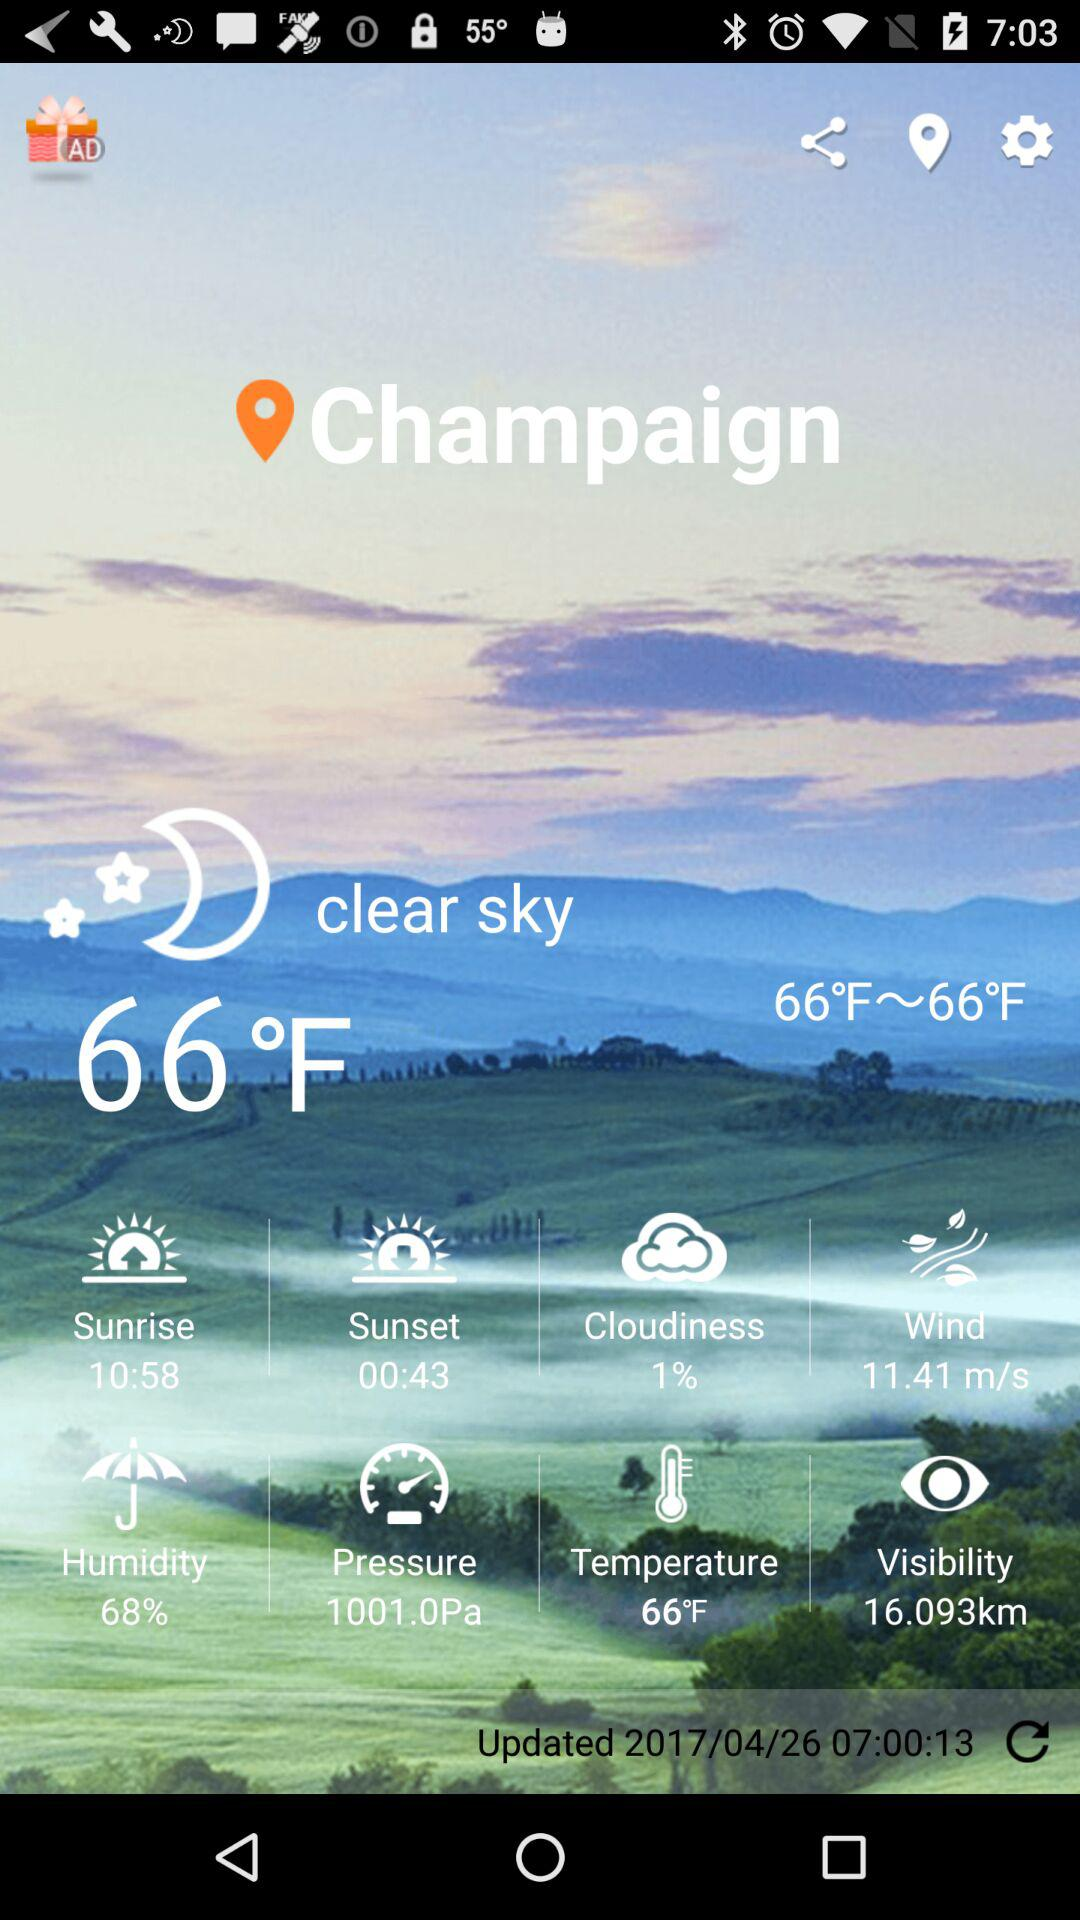What is the sunset time? The sunset time is 00:43. 